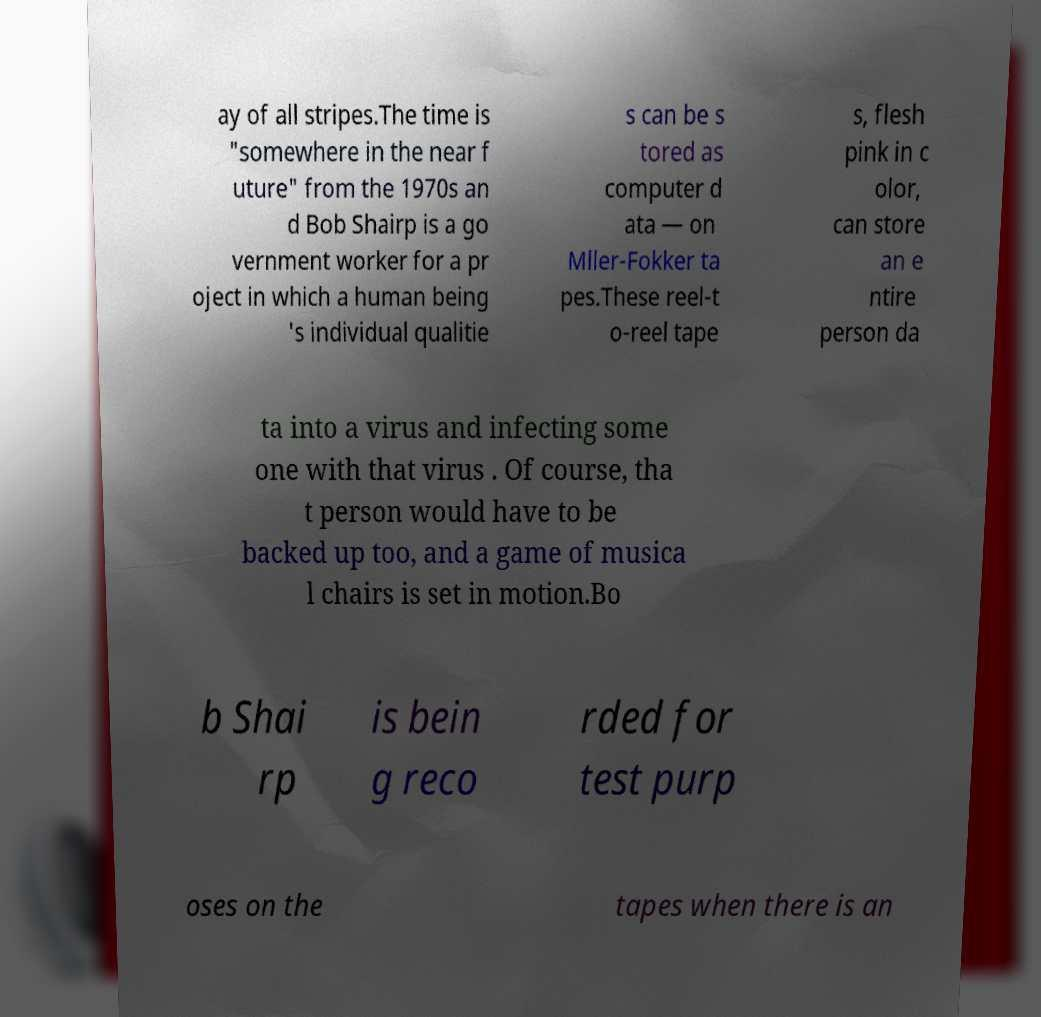Please identify and transcribe the text found in this image. ay of all stripes.The time is "somewhere in the near f uture" from the 1970s an d Bob Shairp is a go vernment worker for a pr oject in which a human being 's individual qualitie s can be s tored as computer d ata — on Mller-Fokker ta pes.These reel-t o-reel tape s, flesh pink in c olor, can store an e ntire person da ta into a virus and infecting some one with that virus . Of course, tha t person would have to be backed up too, and a game of musica l chairs is set in motion.Bo b Shai rp is bein g reco rded for test purp oses on the tapes when there is an 